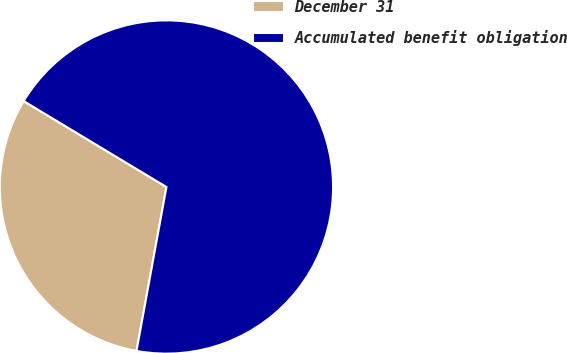Convert chart to OTSL. <chart><loc_0><loc_0><loc_500><loc_500><pie_chart><fcel>December 31<fcel>Accumulated benefit obligation<nl><fcel>30.75%<fcel>69.25%<nl></chart> 